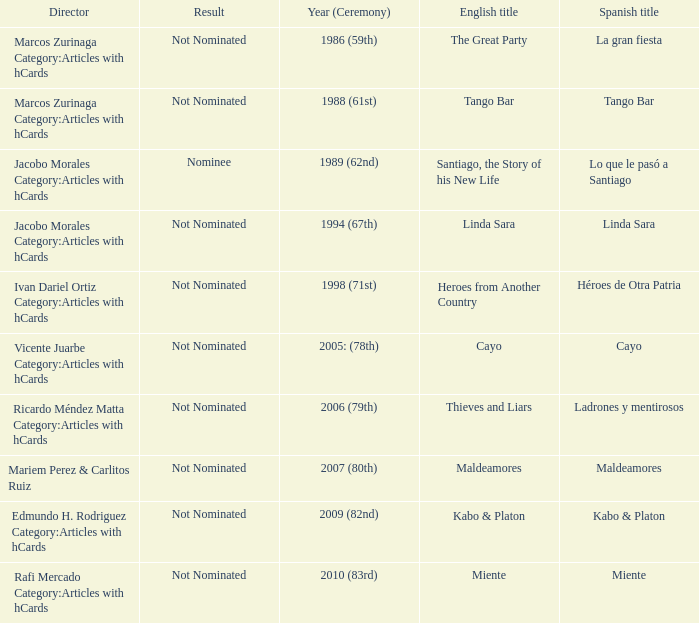What was the English title fo the film that was a nominee? Santiago, the Story of his New Life. 